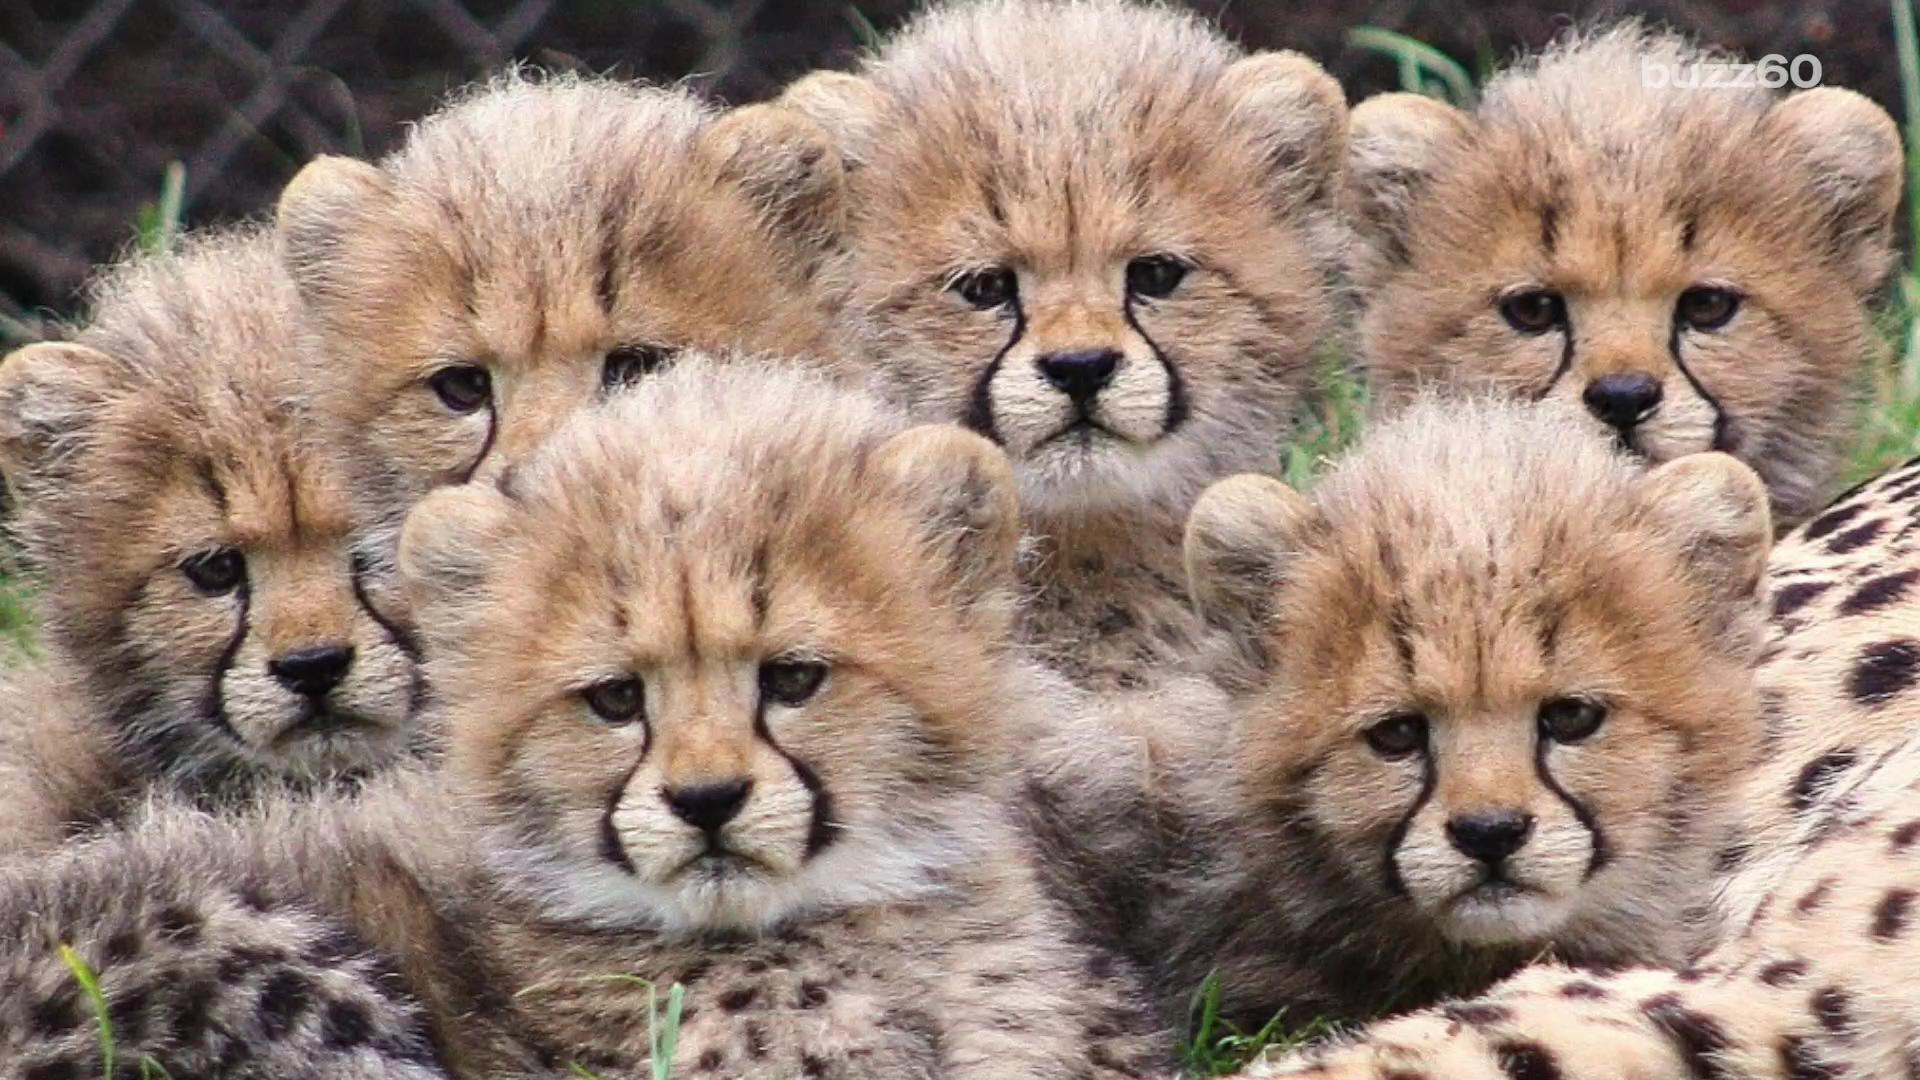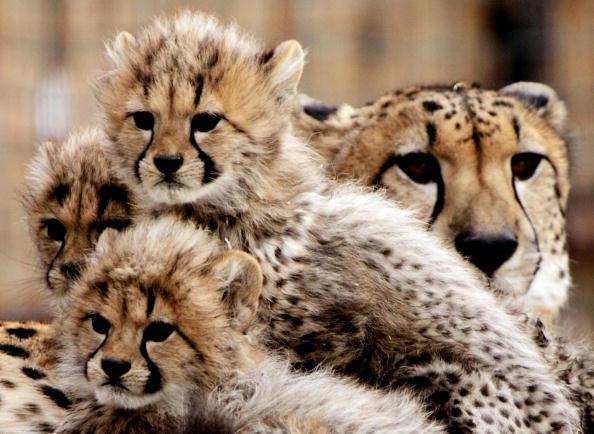The first image is the image on the left, the second image is the image on the right. Examine the images to the left and right. Is the description "One image shows at least two cheetah kittens to the left of an adult cheetah's face." accurate? Answer yes or no. Yes. 